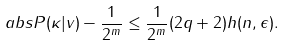Convert formula to latex. <formula><loc_0><loc_0><loc_500><loc_500>\ a b s { P ( \kappa | v ) - \frac { 1 } { 2 ^ { m } } } \leq \frac { 1 } { 2 ^ { m } } ( 2 q + 2 ) h ( n , \epsilon ) .</formula> 